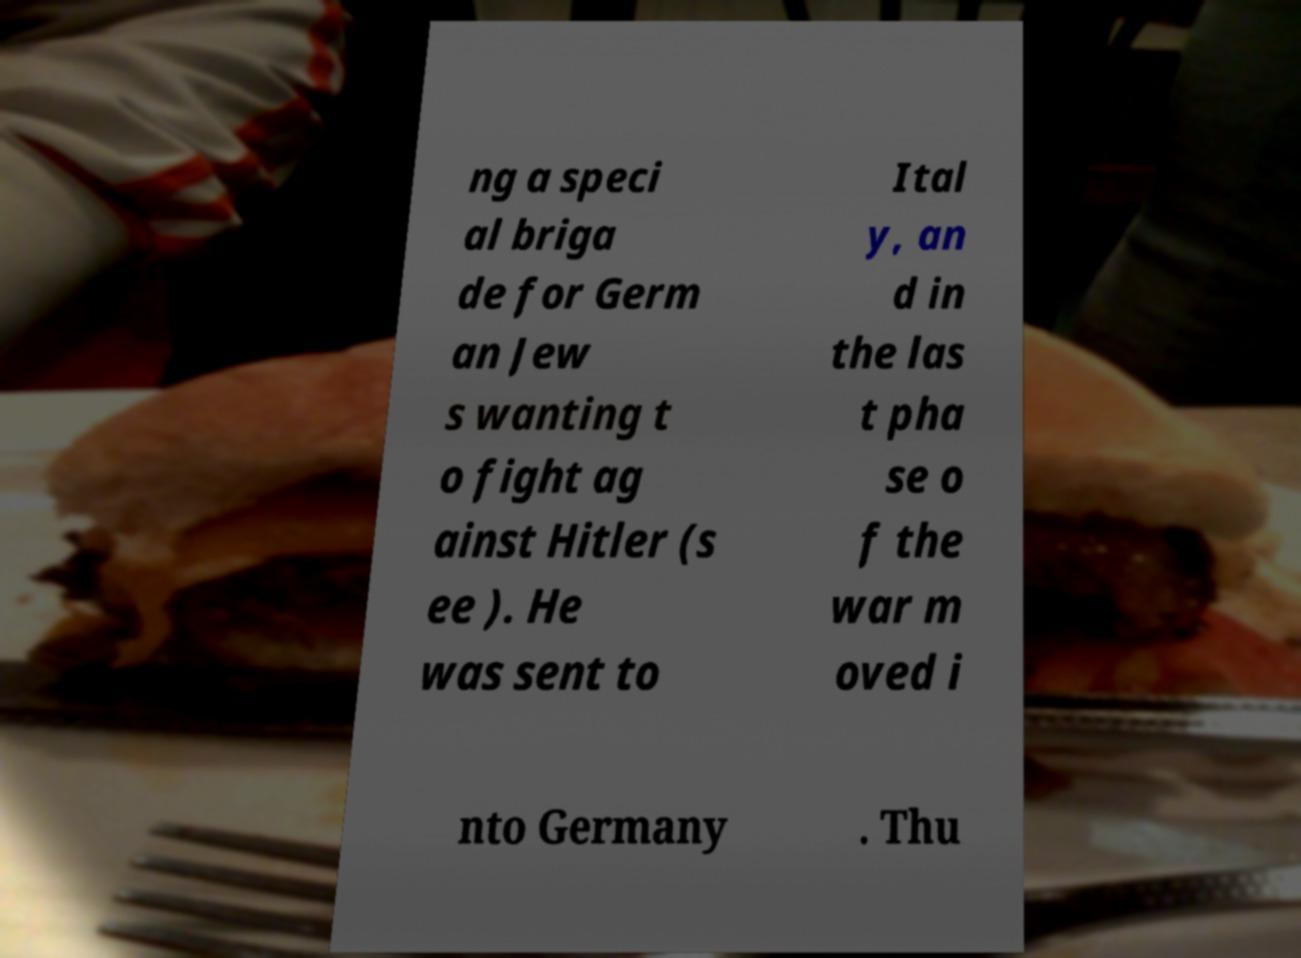Please identify and transcribe the text found in this image. ng a speci al briga de for Germ an Jew s wanting t o fight ag ainst Hitler (s ee ). He was sent to Ital y, an d in the las t pha se o f the war m oved i nto Germany . Thu 